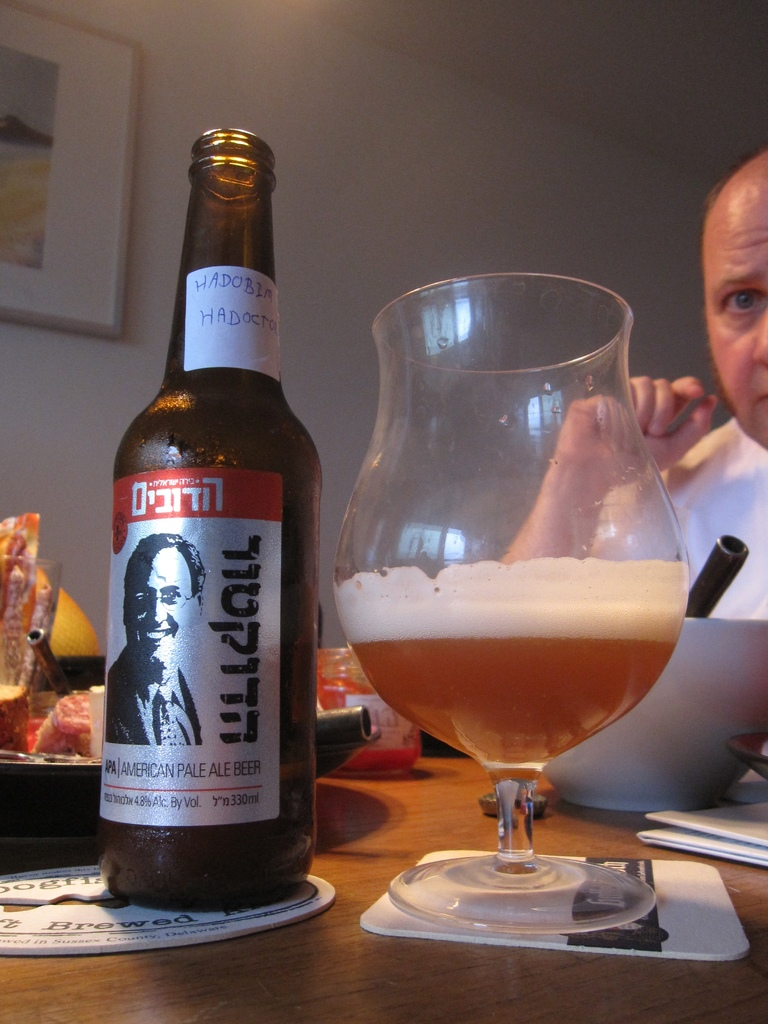Provide a one-sentence caption for the provided image.
Reference OCR token: HADOBLA, HADOC, OT, SOHE, AVERICANP, PALE, AMERICANPALLE, LEBEER, BEER, 48AlcByVol, s"m330ml A man eating at a dinner table and drinking an American Pale Ale beer. 